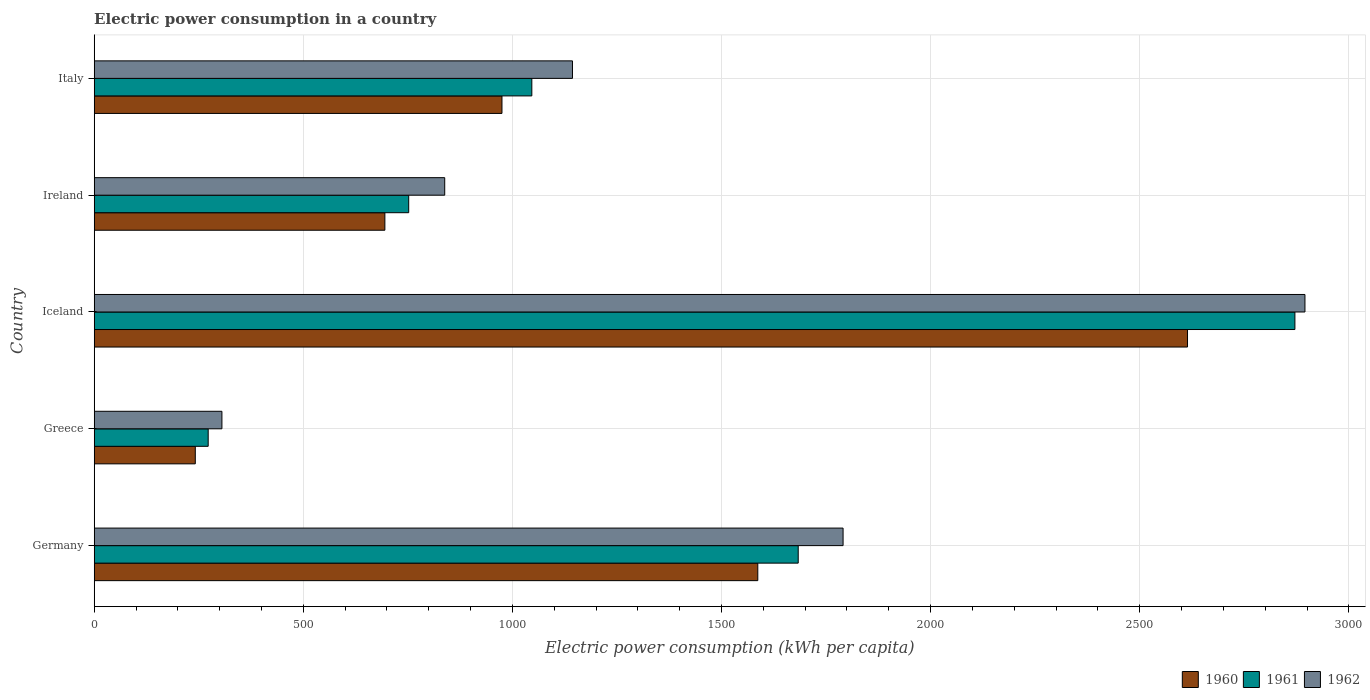How many groups of bars are there?
Offer a very short reply. 5. Are the number of bars per tick equal to the number of legend labels?
Make the answer very short. Yes. Are the number of bars on each tick of the Y-axis equal?
Make the answer very short. Yes. How many bars are there on the 5th tick from the top?
Offer a very short reply. 3. How many bars are there on the 4th tick from the bottom?
Your answer should be very brief. 3. In how many cases, is the number of bars for a given country not equal to the number of legend labels?
Your response must be concise. 0. What is the electric power consumption in in 1962 in Ireland?
Offer a terse response. 838.14. Across all countries, what is the maximum electric power consumption in in 1960?
Ensure brevity in your answer.  2614.28. Across all countries, what is the minimum electric power consumption in in 1961?
Your answer should be very brief. 272.56. In which country was the electric power consumption in in 1960 maximum?
Make the answer very short. Iceland. In which country was the electric power consumption in in 1960 minimum?
Provide a short and direct response. Greece. What is the total electric power consumption in in 1960 in the graph?
Your answer should be compact. 6112.83. What is the difference between the electric power consumption in in 1960 in Germany and that in Greece?
Offer a terse response. 1345.02. What is the difference between the electric power consumption in in 1962 in Italy and the electric power consumption in in 1960 in Germany?
Give a very brief answer. -443.14. What is the average electric power consumption in in 1960 per country?
Give a very brief answer. 1222.57. What is the difference between the electric power consumption in in 1962 and electric power consumption in in 1961 in Ireland?
Your answer should be very brief. 86.12. In how many countries, is the electric power consumption in in 1962 greater than 1900 kWh per capita?
Make the answer very short. 1. What is the ratio of the electric power consumption in in 1961 in Greece to that in Ireland?
Ensure brevity in your answer.  0.36. Is the electric power consumption in in 1962 in Germany less than that in Ireland?
Provide a short and direct response. No. What is the difference between the highest and the second highest electric power consumption in in 1961?
Your response must be concise. 1187.63. What is the difference between the highest and the lowest electric power consumption in in 1961?
Keep it short and to the point. 2598.48. In how many countries, is the electric power consumption in in 1962 greater than the average electric power consumption in in 1962 taken over all countries?
Ensure brevity in your answer.  2. Is the sum of the electric power consumption in in 1960 in Iceland and Italy greater than the maximum electric power consumption in in 1962 across all countries?
Keep it short and to the point. Yes. How many bars are there?
Make the answer very short. 15. How many countries are there in the graph?
Your answer should be compact. 5. What is the difference between two consecutive major ticks on the X-axis?
Make the answer very short. 500. Does the graph contain any zero values?
Provide a short and direct response. No. What is the title of the graph?
Keep it short and to the point. Electric power consumption in a country. Does "2012" appear as one of the legend labels in the graph?
Give a very brief answer. No. What is the label or title of the X-axis?
Offer a very short reply. Electric power consumption (kWh per capita). What is the label or title of the Y-axis?
Your response must be concise. Country. What is the Electric power consumption (kWh per capita) in 1960 in Germany?
Your response must be concise. 1586.75. What is the Electric power consumption (kWh per capita) in 1961 in Germany?
Your answer should be compact. 1683.41. What is the Electric power consumption (kWh per capita) of 1962 in Germany?
Give a very brief answer. 1790.69. What is the Electric power consumption (kWh per capita) of 1960 in Greece?
Give a very brief answer. 241.73. What is the Electric power consumption (kWh per capita) in 1961 in Greece?
Make the answer very short. 272.56. What is the Electric power consumption (kWh per capita) in 1962 in Greece?
Provide a succinct answer. 305.39. What is the Electric power consumption (kWh per capita) of 1960 in Iceland?
Your answer should be compact. 2614.28. What is the Electric power consumption (kWh per capita) in 1961 in Iceland?
Keep it short and to the point. 2871.04. What is the Electric power consumption (kWh per capita) in 1962 in Iceland?
Offer a very short reply. 2895.09. What is the Electric power consumption (kWh per capita) in 1960 in Ireland?
Your answer should be compact. 695.04. What is the Electric power consumption (kWh per capita) of 1961 in Ireland?
Your answer should be compact. 752.02. What is the Electric power consumption (kWh per capita) of 1962 in Ireland?
Offer a terse response. 838.14. What is the Electric power consumption (kWh per capita) in 1960 in Italy?
Provide a short and direct response. 975.03. What is the Electric power consumption (kWh per capita) in 1961 in Italy?
Keep it short and to the point. 1046.42. What is the Electric power consumption (kWh per capita) of 1962 in Italy?
Your response must be concise. 1143.61. Across all countries, what is the maximum Electric power consumption (kWh per capita) of 1960?
Provide a short and direct response. 2614.28. Across all countries, what is the maximum Electric power consumption (kWh per capita) in 1961?
Give a very brief answer. 2871.04. Across all countries, what is the maximum Electric power consumption (kWh per capita) in 1962?
Provide a succinct answer. 2895.09. Across all countries, what is the minimum Electric power consumption (kWh per capita) of 1960?
Ensure brevity in your answer.  241.73. Across all countries, what is the minimum Electric power consumption (kWh per capita) of 1961?
Your response must be concise. 272.56. Across all countries, what is the minimum Electric power consumption (kWh per capita) of 1962?
Provide a succinct answer. 305.39. What is the total Electric power consumption (kWh per capita) in 1960 in the graph?
Your answer should be very brief. 6112.83. What is the total Electric power consumption (kWh per capita) of 1961 in the graph?
Your answer should be compact. 6625.45. What is the total Electric power consumption (kWh per capita) of 1962 in the graph?
Make the answer very short. 6972.9. What is the difference between the Electric power consumption (kWh per capita) in 1960 in Germany and that in Greece?
Make the answer very short. 1345.02. What is the difference between the Electric power consumption (kWh per capita) in 1961 in Germany and that in Greece?
Keep it short and to the point. 1410.85. What is the difference between the Electric power consumption (kWh per capita) of 1962 in Germany and that in Greece?
Offer a terse response. 1485.3. What is the difference between the Electric power consumption (kWh per capita) of 1960 in Germany and that in Iceland?
Offer a very short reply. -1027.53. What is the difference between the Electric power consumption (kWh per capita) of 1961 in Germany and that in Iceland?
Provide a short and direct response. -1187.63. What is the difference between the Electric power consumption (kWh per capita) of 1962 in Germany and that in Iceland?
Make the answer very short. -1104.4. What is the difference between the Electric power consumption (kWh per capita) of 1960 in Germany and that in Ireland?
Give a very brief answer. 891.71. What is the difference between the Electric power consumption (kWh per capita) in 1961 in Germany and that in Ireland?
Keep it short and to the point. 931.4. What is the difference between the Electric power consumption (kWh per capita) in 1962 in Germany and that in Ireland?
Ensure brevity in your answer.  952.55. What is the difference between the Electric power consumption (kWh per capita) of 1960 in Germany and that in Italy?
Provide a succinct answer. 611.72. What is the difference between the Electric power consumption (kWh per capita) of 1961 in Germany and that in Italy?
Your answer should be very brief. 637. What is the difference between the Electric power consumption (kWh per capita) of 1962 in Germany and that in Italy?
Your answer should be very brief. 647.08. What is the difference between the Electric power consumption (kWh per capita) of 1960 in Greece and that in Iceland?
Ensure brevity in your answer.  -2372.56. What is the difference between the Electric power consumption (kWh per capita) in 1961 in Greece and that in Iceland?
Offer a very short reply. -2598.48. What is the difference between the Electric power consumption (kWh per capita) of 1962 in Greece and that in Iceland?
Your answer should be compact. -2589.7. What is the difference between the Electric power consumption (kWh per capita) of 1960 in Greece and that in Ireland?
Keep it short and to the point. -453.32. What is the difference between the Electric power consumption (kWh per capita) in 1961 in Greece and that in Ireland?
Ensure brevity in your answer.  -479.45. What is the difference between the Electric power consumption (kWh per capita) of 1962 in Greece and that in Ireland?
Provide a succinct answer. -532.75. What is the difference between the Electric power consumption (kWh per capita) of 1960 in Greece and that in Italy?
Offer a terse response. -733.3. What is the difference between the Electric power consumption (kWh per capita) in 1961 in Greece and that in Italy?
Your response must be concise. -773.85. What is the difference between the Electric power consumption (kWh per capita) of 1962 in Greece and that in Italy?
Ensure brevity in your answer.  -838.22. What is the difference between the Electric power consumption (kWh per capita) of 1960 in Iceland and that in Ireland?
Provide a succinct answer. 1919.24. What is the difference between the Electric power consumption (kWh per capita) of 1961 in Iceland and that in Ireland?
Provide a short and direct response. 2119.03. What is the difference between the Electric power consumption (kWh per capita) of 1962 in Iceland and that in Ireland?
Give a very brief answer. 2056.95. What is the difference between the Electric power consumption (kWh per capita) in 1960 in Iceland and that in Italy?
Give a very brief answer. 1639.26. What is the difference between the Electric power consumption (kWh per capita) in 1961 in Iceland and that in Italy?
Your response must be concise. 1824.63. What is the difference between the Electric power consumption (kWh per capita) of 1962 in Iceland and that in Italy?
Offer a very short reply. 1751.48. What is the difference between the Electric power consumption (kWh per capita) of 1960 in Ireland and that in Italy?
Give a very brief answer. -279.98. What is the difference between the Electric power consumption (kWh per capita) in 1961 in Ireland and that in Italy?
Give a very brief answer. -294.4. What is the difference between the Electric power consumption (kWh per capita) of 1962 in Ireland and that in Italy?
Your answer should be compact. -305.47. What is the difference between the Electric power consumption (kWh per capita) of 1960 in Germany and the Electric power consumption (kWh per capita) of 1961 in Greece?
Your answer should be very brief. 1314.19. What is the difference between the Electric power consumption (kWh per capita) of 1960 in Germany and the Electric power consumption (kWh per capita) of 1962 in Greece?
Make the answer very short. 1281.36. What is the difference between the Electric power consumption (kWh per capita) of 1961 in Germany and the Electric power consumption (kWh per capita) of 1962 in Greece?
Make the answer very short. 1378.03. What is the difference between the Electric power consumption (kWh per capita) in 1960 in Germany and the Electric power consumption (kWh per capita) in 1961 in Iceland?
Keep it short and to the point. -1284.29. What is the difference between the Electric power consumption (kWh per capita) of 1960 in Germany and the Electric power consumption (kWh per capita) of 1962 in Iceland?
Provide a succinct answer. -1308.34. What is the difference between the Electric power consumption (kWh per capita) in 1961 in Germany and the Electric power consumption (kWh per capita) in 1962 in Iceland?
Your response must be concise. -1211.67. What is the difference between the Electric power consumption (kWh per capita) of 1960 in Germany and the Electric power consumption (kWh per capita) of 1961 in Ireland?
Keep it short and to the point. 834.73. What is the difference between the Electric power consumption (kWh per capita) of 1960 in Germany and the Electric power consumption (kWh per capita) of 1962 in Ireland?
Offer a terse response. 748.61. What is the difference between the Electric power consumption (kWh per capita) of 1961 in Germany and the Electric power consumption (kWh per capita) of 1962 in Ireland?
Give a very brief answer. 845.28. What is the difference between the Electric power consumption (kWh per capita) in 1960 in Germany and the Electric power consumption (kWh per capita) in 1961 in Italy?
Your response must be concise. 540.33. What is the difference between the Electric power consumption (kWh per capita) of 1960 in Germany and the Electric power consumption (kWh per capita) of 1962 in Italy?
Ensure brevity in your answer.  443.14. What is the difference between the Electric power consumption (kWh per capita) of 1961 in Germany and the Electric power consumption (kWh per capita) of 1962 in Italy?
Provide a succinct answer. 539.81. What is the difference between the Electric power consumption (kWh per capita) of 1960 in Greece and the Electric power consumption (kWh per capita) of 1961 in Iceland?
Make the answer very short. -2629.32. What is the difference between the Electric power consumption (kWh per capita) in 1960 in Greece and the Electric power consumption (kWh per capita) in 1962 in Iceland?
Your answer should be compact. -2653.36. What is the difference between the Electric power consumption (kWh per capita) in 1961 in Greece and the Electric power consumption (kWh per capita) in 1962 in Iceland?
Offer a terse response. -2622.52. What is the difference between the Electric power consumption (kWh per capita) in 1960 in Greece and the Electric power consumption (kWh per capita) in 1961 in Ireland?
Give a very brief answer. -510.29. What is the difference between the Electric power consumption (kWh per capita) in 1960 in Greece and the Electric power consumption (kWh per capita) in 1962 in Ireland?
Your response must be concise. -596.41. What is the difference between the Electric power consumption (kWh per capita) in 1961 in Greece and the Electric power consumption (kWh per capita) in 1962 in Ireland?
Offer a very short reply. -565.57. What is the difference between the Electric power consumption (kWh per capita) in 1960 in Greece and the Electric power consumption (kWh per capita) in 1961 in Italy?
Your response must be concise. -804.69. What is the difference between the Electric power consumption (kWh per capita) of 1960 in Greece and the Electric power consumption (kWh per capita) of 1962 in Italy?
Offer a very short reply. -901.88. What is the difference between the Electric power consumption (kWh per capita) in 1961 in Greece and the Electric power consumption (kWh per capita) in 1962 in Italy?
Provide a succinct answer. -871.04. What is the difference between the Electric power consumption (kWh per capita) in 1960 in Iceland and the Electric power consumption (kWh per capita) in 1961 in Ireland?
Give a very brief answer. 1862.26. What is the difference between the Electric power consumption (kWh per capita) in 1960 in Iceland and the Electric power consumption (kWh per capita) in 1962 in Ireland?
Offer a terse response. 1776.14. What is the difference between the Electric power consumption (kWh per capita) in 1961 in Iceland and the Electric power consumption (kWh per capita) in 1962 in Ireland?
Provide a short and direct response. 2032.91. What is the difference between the Electric power consumption (kWh per capita) in 1960 in Iceland and the Electric power consumption (kWh per capita) in 1961 in Italy?
Offer a terse response. 1567.87. What is the difference between the Electric power consumption (kWh per capita) of 1960 in Iceland and the Electric power consumption (kWh per capita) of 1962 in Italy?
Offer a very short reply. 1470.68. What is the difference between the Electric power consumption (kWh per capita) in 1961 in Iceland and the Electric power consumption (kWh per capita) in 1962 in Italy?
Offer a terse response. 1727.44. What is the difference between the Electric power consumption (kWh per capita) in 1960 in Ireland and the Electric power consumption (kWh per capita) in 1961 in Italy?
Your response must be concise. -351.37. What is the difference between the Electric power consumption (kWh per capita) of 1960 in Ireland and the Electric power consumption (kWh per capita) of 1962 in Italy?
Offer a very short reply. -448.56. What is the difference between the Electric power consumption (kWh per capita) of 1961 in Ireland and the Electric power consumption (kWh per capita) of 1962 in Italy?
Provide a short and direct response. -391.59. What is the average Electric power consumption (kWh per capita) of 1960 per country?
Provide a short and direct response. 1222.57. What is the average Electric power consumption (kWh per capita) of 1961 per country?
Ensure brevity in your answer.  1325.09. What is the average Electric power consumption (kWh per capita) of 1962 per country?
Your response must be concise. 1394.58. What is the difference between the Electric power consumption (kWh per capita) in 1960 and Electric power consumption (kWh per capita) in 1961 in Germany?
Make the answer very short. -96.67. What is the difference between the Electric power consumption (kWh per capita) in 1960 and Electric power consumption (kWh per capita) in 1962 in Germany?
Keep it short and to the point. -203.94. What is the difference between the Electric power consumption (kWh per capita) in 1961 and Electric power consumption (kWh per capita) in 1962 in Germany?
Offer a very short reply. -107.27. What is the difference between the Electric power consumption (kWh per capita) of 1960 and Electric power consumption (kWh per capita) of 1961 in Greece?
Your answer should be very brief. -30.84. What is the difference between the Electric power consumption (kWh per capita) in 1960 and Electric power consumption (kWh per capita) in 1962 in Greece?
Offer a very short reply. -63.66. What is the difference between the Electric power consumption (kWh per capita) of 1961 and Electric power consumption (kWh per capita) of 1962 in Greece?
Offer a very short reply. -32.83. What is the difference between the Electric power consumption (kWh per capita) in 1960 and Electric power consumption (kWh per capita) in 1961 in Iceland?
Your response must be concise. -256.76. What is the difference between the Electric power consumption (kWh per capita) in 1960 and Electric power consumption (kWh per capita) in 1962 in Iceland?
Provide a succinct answer. -280.8. What is the difference between the Electric power consumption (kWh per capita) of 1961 and Electric power consumption (kWh per capita) of 1962 in Iceland?
Offer a terse response. -24.04. What is the difference between the Electric power consumption (kWh per capita) of 1960 and Electric power consumption (kWh per capita) of 1961 in Ireland?
Ensure brevity in your answer.  -56.97. What is the difference between the Electric power consumption (kWh per capita) of 1960 and Electric power consumption (kWh per capita) of 1962 in Ireland?
Make the answer very short. -143.09. What is the difference between the Electric power consumption (kWh per capita) in 1961 and Electric power consumption (kWh per capita) in 1962 in Ireland?
Provide a short and direct response. -86.12. What is the difference between the Electric power consumption (kWh per capita) in 1960 and Electric power consumption (kWh per capita) in 1961 in Italy?
Ensure brevity in your answer.  -71.39. What is the difference between the Electric power consumption (kWh per capita) in 1960 and Electric power consumption (kWh per capita) in 1962 in Italy?
Give a very brief answer. -168.58. What is the difference between the Electric power consumption (kWh per capita) in 1961 and Electric power consumption (kWh per capita) in 1962 in Italy?
Ensure brevity in your answer.  -97.19. What is the ratio of the Electric power consumption (kWh per capita) of 1960 in Germany to that in Greece?
Provide a succinct answer. 6.56. What is the ratio of the Electric power consumption (kWh per capita) in 1961 in Germany to that in Greece?
Offer a terse response. 6.18. What is the ratio of the Electric power consumption (kWh per capita) of 1962 in Germany to that in Greece?
Give a very brief answer. 5.86. What is the ratio of the Electric power consumption (kWh per capita) of 1960 in Germany to that in Iceland?
Provide a succinct answer. 0.61. What is the ratio of the Electric power consumption (kWh per capita) of 1961 in Germany to that in Iceland?
Your answer should be compact. 0.59. What is the ratio of the Electric power consumption (kWh per capita) in 1962 in Germany to that in Iceland?
Your answer should be compact. 0.62. What is the ratio of the Electric power consumption (kWh per capita) of 1960 in Germany to that in Ireland?
Provide a short and direct response. 2.28. What is the ratio of the Electric power consumption (kWh per capita) in 1961 in Germany to that in Ireland?
Provide a short and direct response. 2.24. What is the ratio of the Electric power consumption (kWh per capita) of 1962 in Germany to that in Ireland?
Ensure brevity in your answer.  2.14. What is the ratio of the Electric power consumption (kWh per capita) in 1960 in Germany to that in Italy?
Give a very brief answer. 1.63. What is the ratio of the Electric power consumption (kWh per capita) of 1961 in Germany to that in Italy?
Your answer should be compact. 1.61. What is the ratio of the Electric power consumption (kWh per capita) of 1962 in Germany to that in Italy?
Your answer should be very brief. 1.57. What is the ratio of the Electric power consumption (kWh per capita) of 1960 in Greece to that in Iceland?
Give a very brief answer. 0.09. What is the ratio of the Electric power consumption (kWh per capita) of 1961 in Greece to that in Iceland?
Your response must be concise. 0.09. What is the ratio of the Electric power consumption (kWh per capita) in 1962 in Greece to that in Iceland?
Your answer should be very brief. 0.11. What is the ratio of the Electric power consumption (kWh per capita) in 1960 in Greece to that in Ireland?
Your answer should be very brief. 0.35. What is the ratio of the Electric power consumption (kWh per capita) in 1961 in Greece to that in Ireland?
Provide a short and direct response. 0.36. What is the ratio of the Electric power consumption (kWh per capita) in 1962 in Greece to that in Ireland?
Your answer should be compact. 0.36. What is the ratio of the Electric power consumption (kWh per capita) of 1960 in Greece to that in Italy?
Make the answer very short. 0.25. What is the ratio of the Electric power consumption (kWh per capita) of 1961 in Greece to that in Italy?
Give a very brief answer. 0.26. What is the ratio of the Electric power consumption (kWh per capita) of 1962 in Greece to that in Italy?
Provide a succinct answer. 0.27. What is the ratio of the Electric power consumption (kWh per capita) in 1960 in Iceland to that in Ireland?
Your answer should be compact. 3.76. What is the ratio of the Electric power consumption (kWh per capita) in 1961 in Iceland to that in Ireland?
Your answer should be very brief. 3.82. What is the ratio of the Electric power consumption (kWh per capita) of 1962 in Iceland to that in Ireland?
Provide a short and direct response. 3.45. What is the ratio of the Electric power consumption (kWh per capita) of 1960 in Iceland to that in Italy?
Your answer should be very brief. 2.68. What is the ratio of the Electric power consumption (kWh per capita) in 1961 in Iceland to that in Italy?
Provide a succinct answer. 2.74. What is the ratio of the Electric power consumption (kWh per capita) of 1962 in Iceland to that in Italy?
Offer a very short reply. 2.53. What is the ratio of the Electric power consumption (kWh per capita) of 1960 in Ireland to that in Italy?
Make the answer very short. 0.71. What is the ratio of the Electric power consumption (kWh per capita) of 1961 in Ireland to that in Italy?
Provide a short and direct response. 0.72. What is the ratio of the Electric power consumption (kWh per capita) in 1962 in Ireland to that in Italy?
Offer a very short reply. 0.73. What is the difference between the highest and the second highest Electric power consumption (kWh per capita) in 1960?
Keep it short and to the point. 1027.53. What is the difference between the highest and the second highest Electric power consumption (kWh per capita) in 1961?
Your response must be concise. 1187.63. What is the difference between the highest and the second highest Electric power consumption (kWh per capita) in 1962?
Provide a short and direct response. 1104.4. What is the difference between the highest and the lowest Electric power consumption (kWh per capita) of 1960?
Ensure brevity in your answer.  2372.56. What is the difference between the highest and the lowest Electric power consumption (kWh per capita) in 1961?
Your response must be concise. 2598.48. What is the difference between the highest and the lowest Electric power consumption (kWh per capita) of 1962?
Provide a succinct answer. 2589.7. 